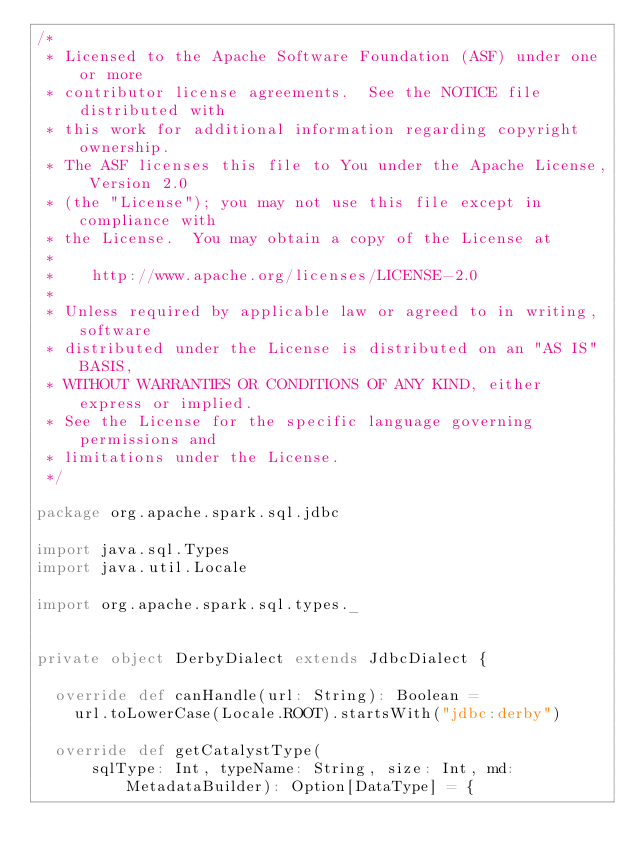<code> <loc_0><loc_0><loc_500><loc_500><_Scala_>/*
 * Licensed to the Apache Software Foundation (ASF) under one or more
 * contributor license agreements.  See the NOTICE file distributed with
 * this work for additional information regarding copyright ownership.
 * The ASF licenses this file to You under the Apache License, Version 2.0
 * (the "License"); you may not use this file except in compliance with
 * the License.  You may obtain a copy of the License at
 *
 *    http://www.apache.org/licenses/LICENSE-2.0
 *
 * Unless required by applicable law or agreed to in writing, software
 * distributed under the License is distributed on an "AS IS" BASIS,
 * WITHOUT WARRANTIES OR CONDITIONS OF ANY KIND, either express or implied.
 * See the License for the specific language governing permissions and
 * limitations under the License.
 */

package org.apache.spark.sql.jdbc

import java.sql.Types
import java.util.Locale

import org.apache.spark.sql.types._


private object DerbyDialect extends JdbcDialect {

  override def canHandle(url: String): Boolean =
    url.toLowerCase(Locale.ROOT).startsWith("jdbc:derby")

  override def getCatalystType(
      sqlType: Int, typeName: String, size: Int, md: MetadataBuilder): Option[DataType] = {</code> 